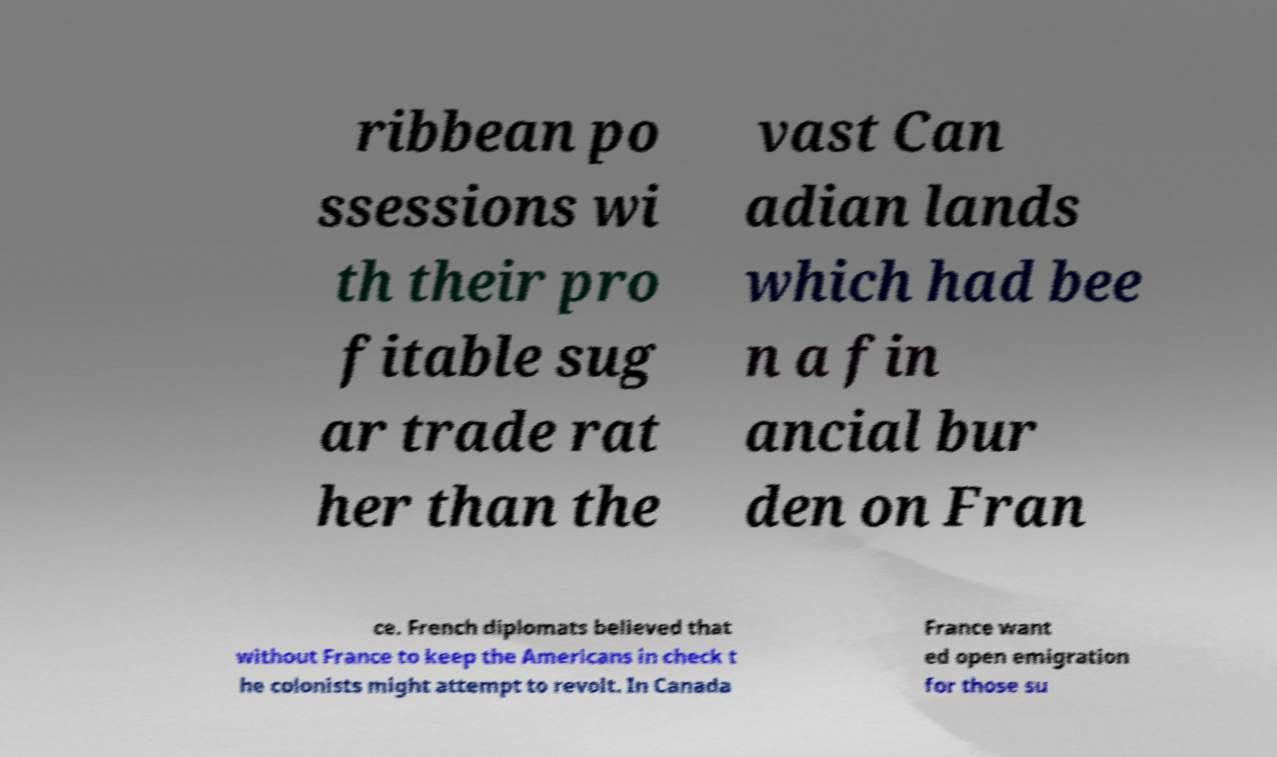Can you accurately transcribe the text from the provided image for me? ribbean po ssessions wi th their pro fitable sug ar trade rat her than the vast Can adian lands which had bee n a fin ancial bur den on Fran ce. French diplomats believed that without France to keep the Americans in check t he colonists might attempt to revolt. In Canada France want ed open emigration for those su 